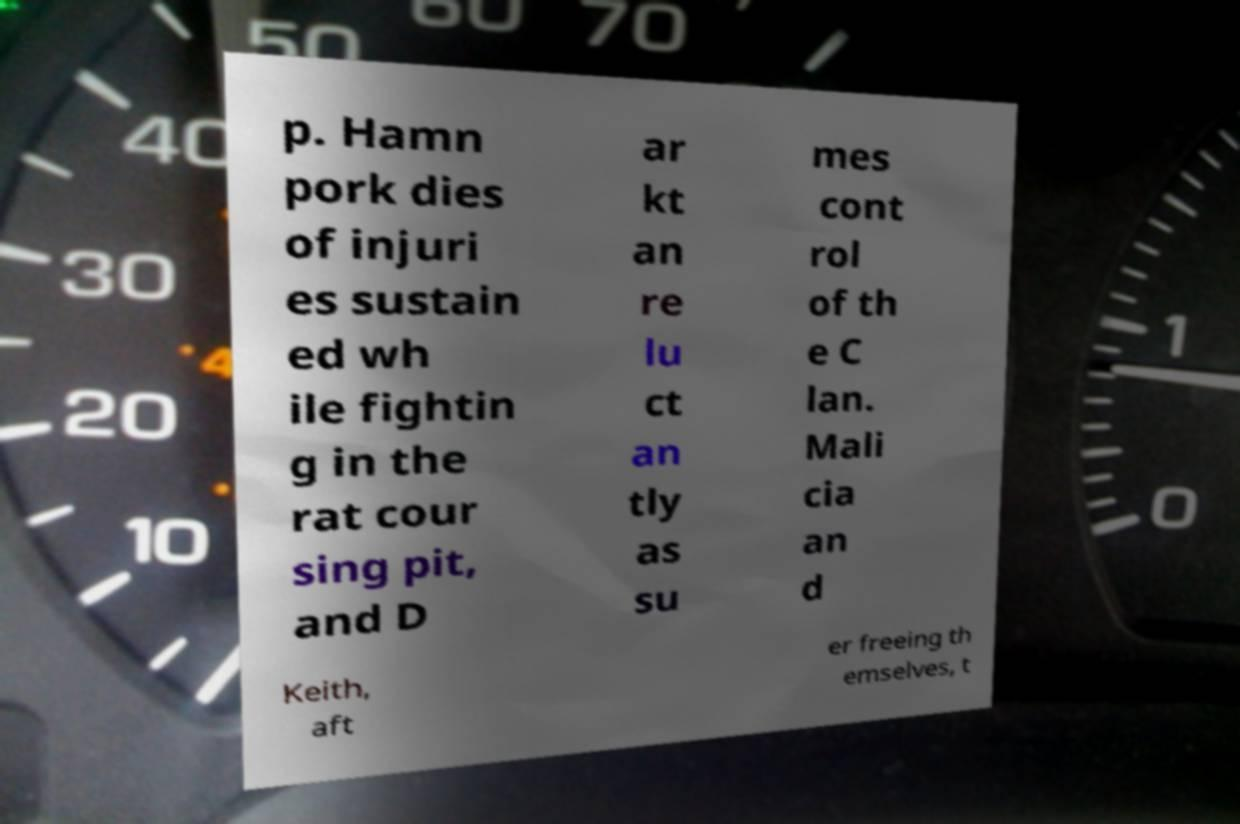Please identify and transcribe the text found in this image. p. Hamn pork dies of injuri es sustain ed wh ile fightin g in the rat cour sing pit, and D ar kt an re lu ct an tly as su mes cont rol of th e C lan. Mali cia an d Keith, aft er freeing th emselves, t 